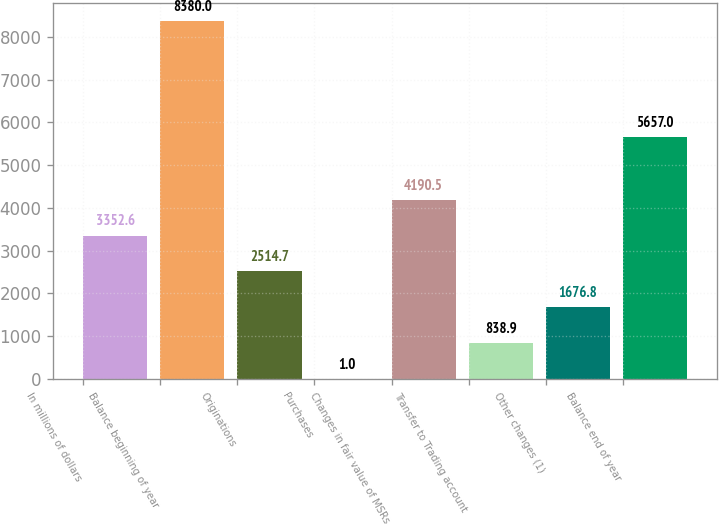<chart> <loc_0><loc_0><loc_500><loc_500><bar_chart><fcel>In millions of dollars<fcel>Balance beginning of year<fcel>Originations<fcel>Purchases<fcel>Changes in fair value of MSRs<fcel>Transfer to Trading account<fcel>Other changes (1)<fcel>Balance end of year<nl><fcel>3352.6<fcel>8380<fcel>2514.7<fcel>1<fcel>4190.5<fcel>838.9<fcel>1676.8<fcel>5657<nl></chart> 